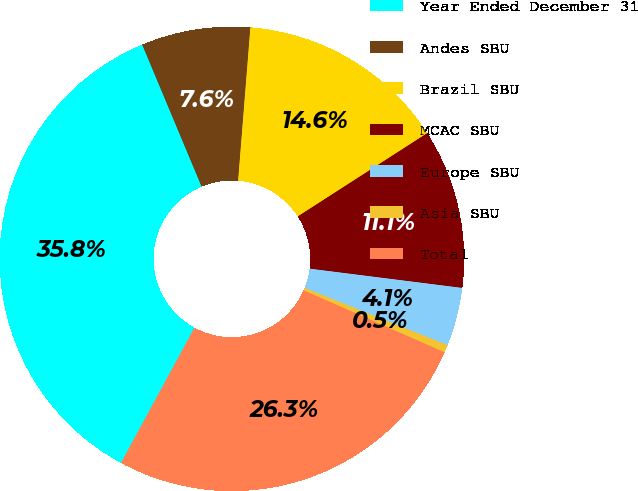Convert chart. <chart><loc_0><loc_0><loc_500><loc_500><pie_chart><fcel>Year Ended December 31<fcel>Andes SBU<fcel>Brazil SBU<fcel>MCAC SBU<fcel>Europe SBU<fcel>Asia SBU<fcel>Total<nl><fcel>35.77%<fcel>7.58%<fcel>14.63%<fcel>11.1%<fcel>4.06%<fcel>0.53%<fcel>26.33%<nl></chart> 